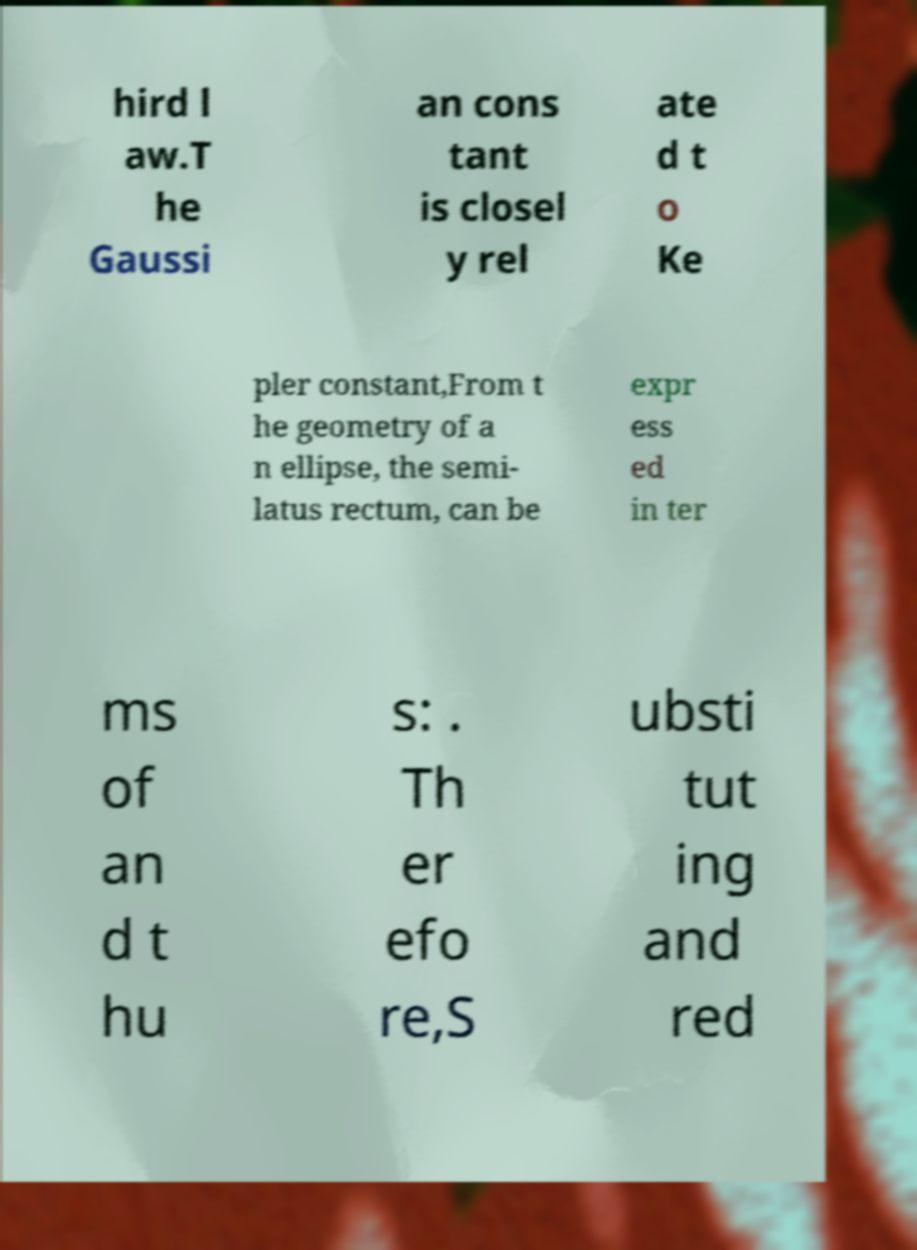Can you read and provide the text displayed in the image?This photo seems to have some interesting text. Can you extract and type it out for me? hird l aw.T he Gaussi an cons tant is closel y rel ate d t o Ke pler constant,From t he geometry of a n ellipse, the semi- latus rectum, can be expr ess ed in ter ms of an d t hu s: . Th er efo re,S ubsti tut ing and red 